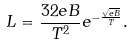Convert formula to latex. <formula><loc_0><loc_0><loc_500><loc_500>L = \frac { 3 2 e B } { T ^ { 2 } } e ^ { - \frac { \sqrt { e B } } { T } } .</formula> 